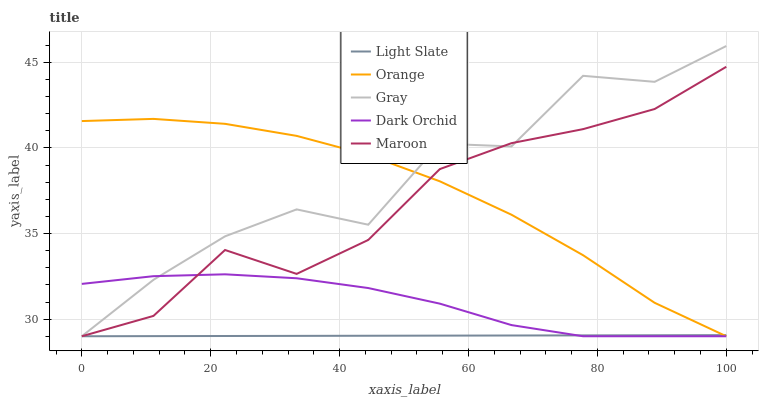Does Light Slate have the minimum area under the curve?
Answer yes or no. Yes. Does Gray have the maximum area under the curve?
Answer yes or no. Yes. Does Orange have the minimum area under the curve?
Answer yes or no. No. Does Orange have the maximum area under the curve?
Answer yes or no. No. Is Light Slate the smoothest?
Answer yes or no. Yes. Is Gray the roughest?
Answer yes or no. Yes. Is Orange the smoothest?
Answer yes or no. No. Is Orange the roughest?
Answer yes or no. No. Does Light Slate have the lowest value?
Answer yes or no. Yes. Does Gray have the highest value?
Answer yes or no. Yes. Does Orange have the highest value?
Answer yes or no. No. Does Dark Orchid intersect Light Slate?
Answer yes or no. Yes. Is Dark Orchid less than Light Slate?
Answer yes or no. No. Is Dark Orchid greater than Light Slate?
Answer yes or no. No. 